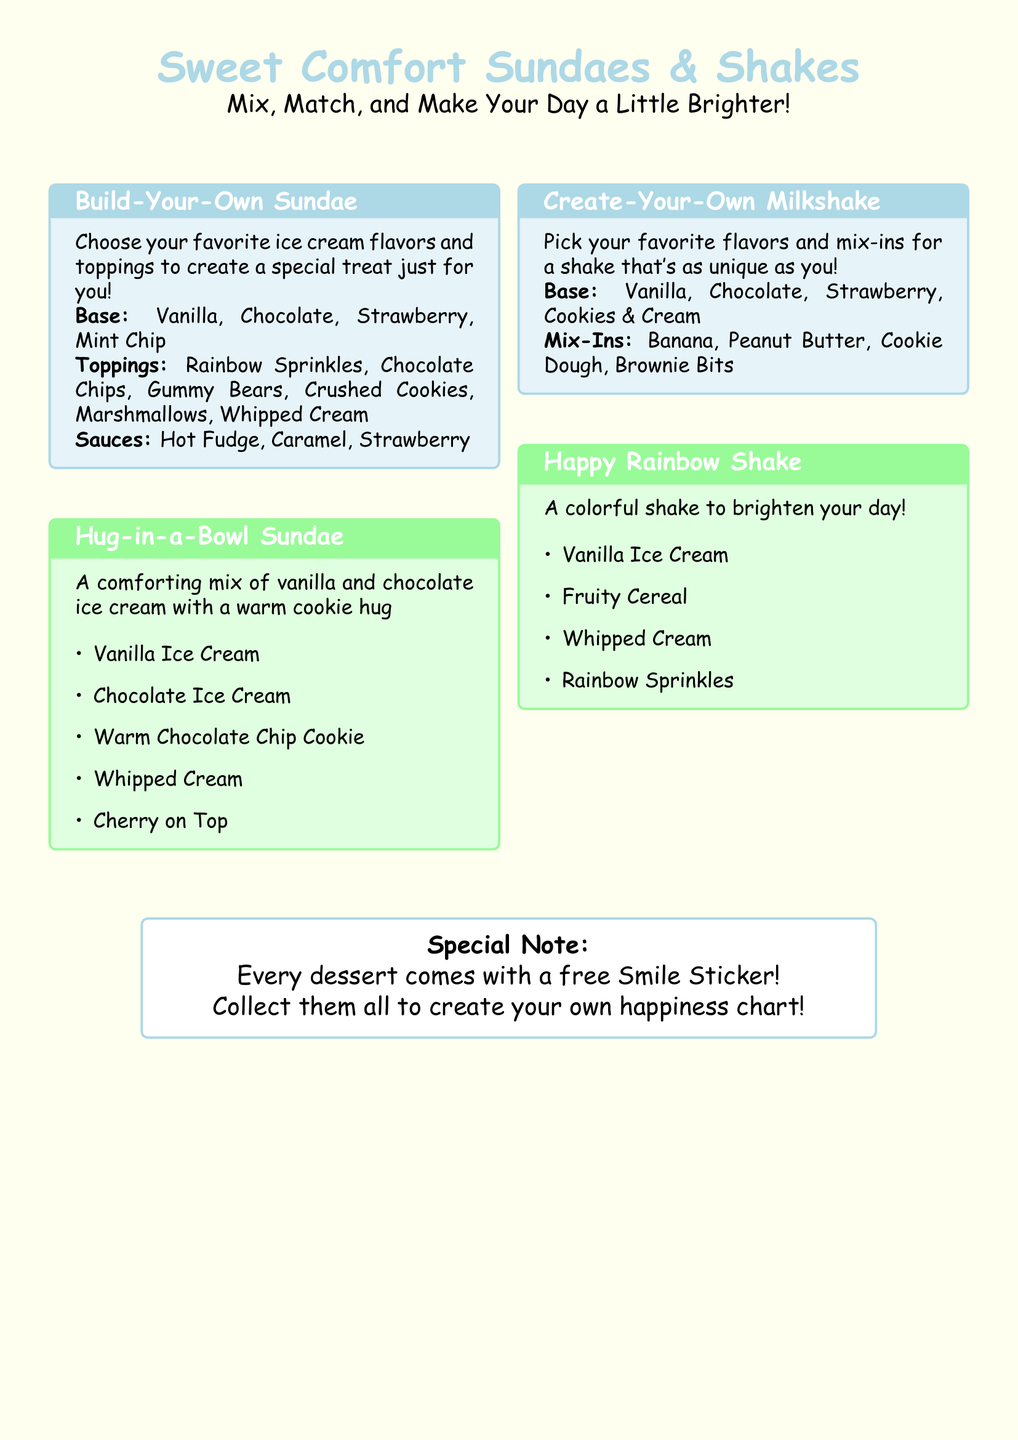What ice cream flavors can I choose for my sundae? The document lists the base ice cream flavors for sundaes, which are Vanilla, Chocolate, Strawberry, and Mint Chip.
Answer: Vanilla, Chocolate, Strawberry, Mint Chip What toppings are available for the Build-Your-Own Sundae? The menu specifies the toppings that can be chosen for the sundae, which include Rainbow Sprinkles, Chocolate Chips, Gummy Bears, Crushed Cookies, Marshmallows, and Whipped Cream.
Answer: Rainbow Sprinkles, Chocolate Chips, Gummy Bears, Crushed Cookies, Marshmallows, Whipped Cream What is the name of the special sundae that includes a warm cookie? The document mentions a specific sundae called the Hug-in-a-Bowl Sundae that includes a warm cookie.
Answer: Hug-in-a-Bowl Sundae How many flavors can be selected for the Create-Your-Own Milkshake? The menu lists four base flavors available for the Create-Your-Own Milkshake, which allows for customization.
Answer: Four What is included with every dessert ordered? The document specifies that every dessert comes with a free Smile Sticker.
Answer: Free Smile Sticker Which milkshake is described as colorful and bright? The menu includes the Happy Rainbow Shake, which is described as colorful.
Answer: Happy Rainbow Shake What is the main ingredient of the Hug-in-a-Bowl Sundae? The primary ingredients of the Hug-in-a-Bowl Sundae are vanilla and chocolate ice cream.
Answer: Vanilla and chocolate ice cream Can I customize my ice cream sundae? Yes, the document indicates that you can mix and match different ice cream flavors and toppings for your sundae.
Answer: Yes What unique feature does the Happy Rainbow Shake have? The Happy Rainbow Shake contains fruity cereal as part of its ingredients, which makes it unique.
Answer: Fruity Cereal 